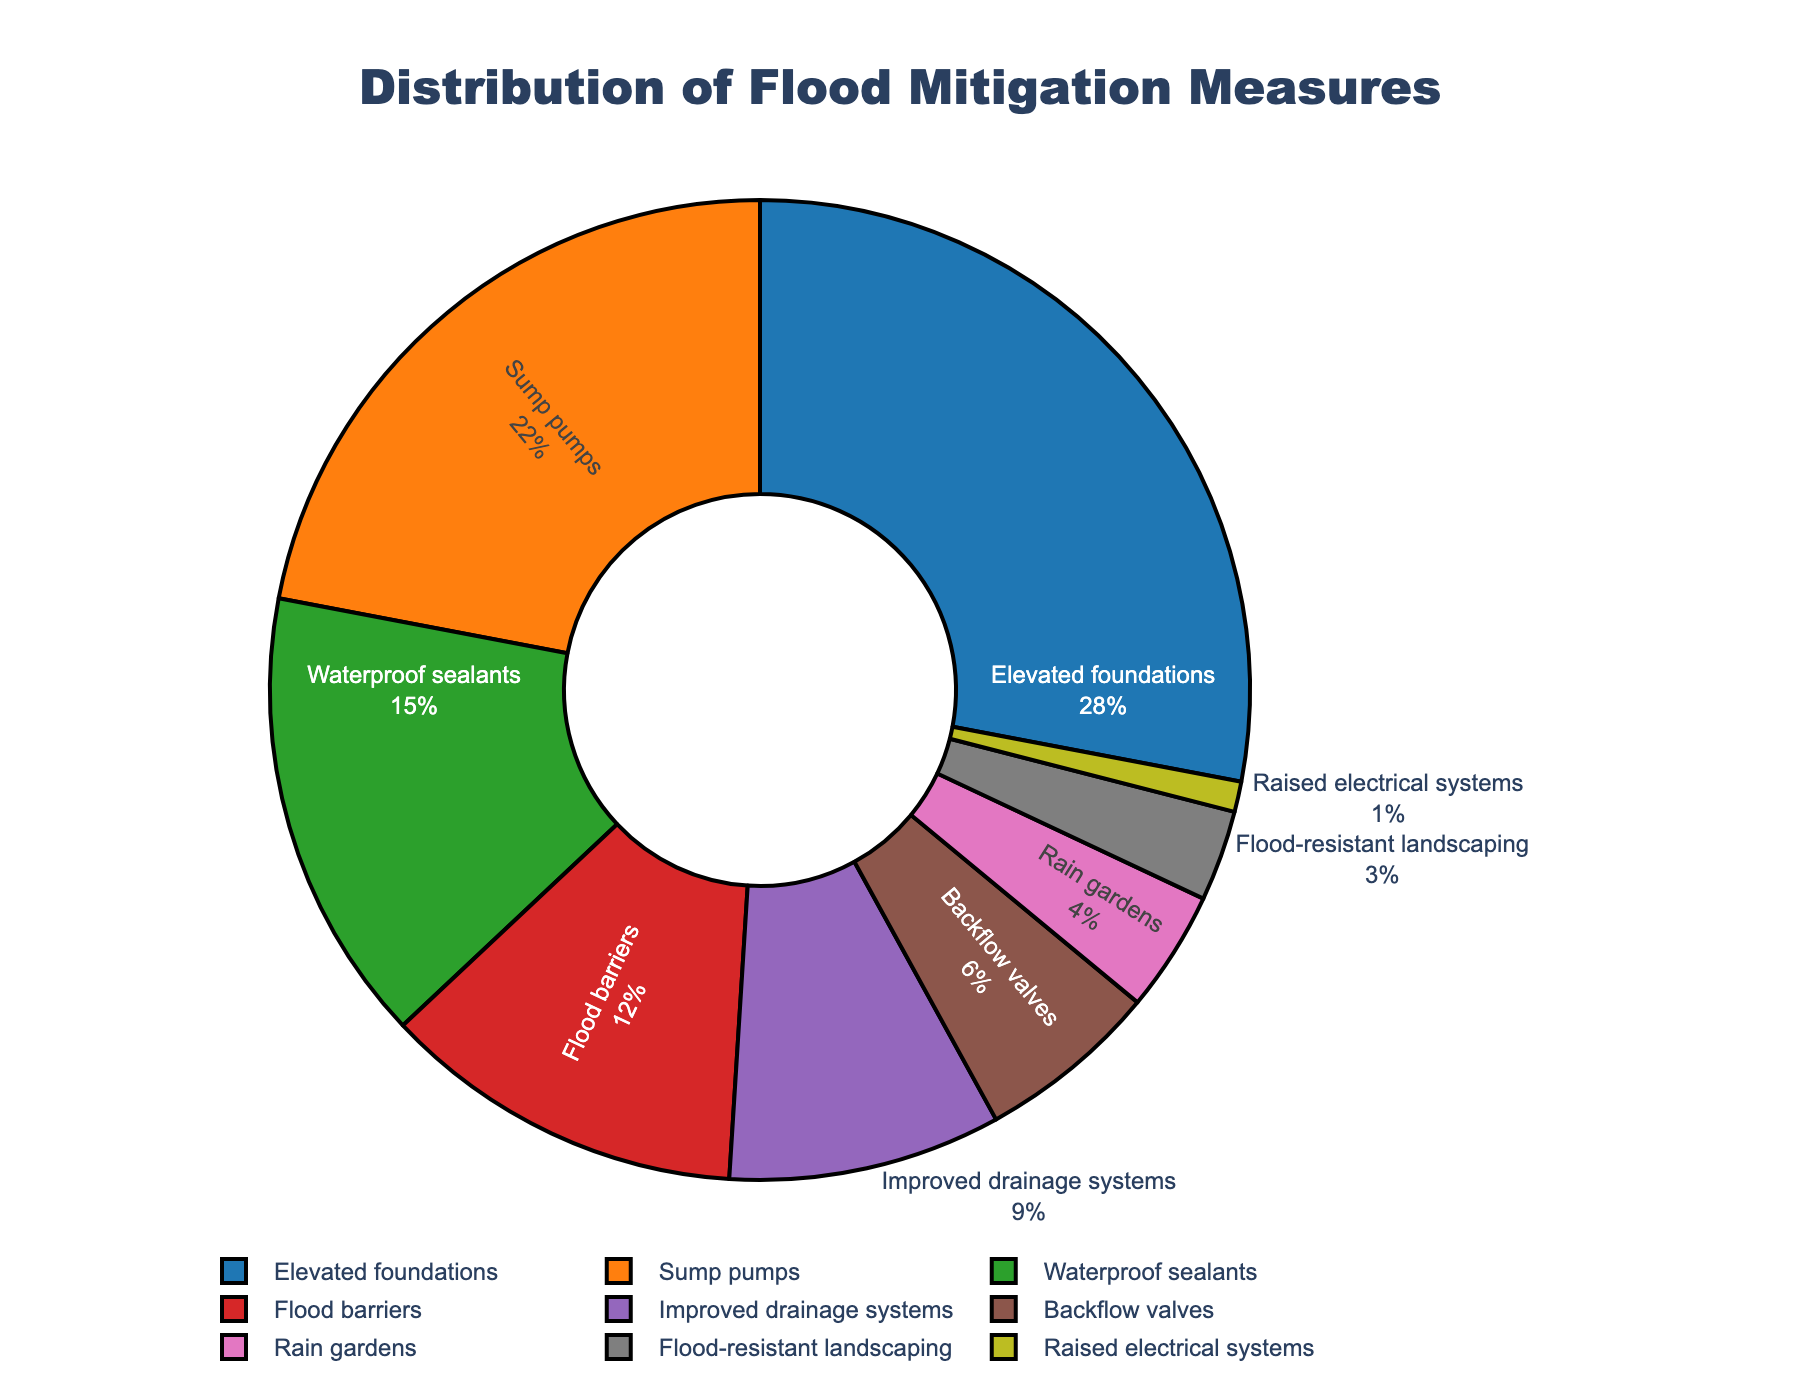Which flood mitigation measure has the highest adoption rate? By examining the pie chart, we identify the measure segment with the largest percentage. "Elevated foundations" has the highest adoption rate at 28%.
Answer: Elevated foundations What is the combined percentage of households that adopted sump pumps and waterproof sealants? To find the combined percentage, add the percentages of sump pumps (22%) and waterproof sealants (15%). Therefore, 22% + 15% = 37%.
Answer: 37% How does the adoption rate of flood barriers compare to that of improved drainage systems? We look at the two segments labeled "Flood barriers" and "Improved drainage systems". Flood barriers have a 12% adoption rate, while improved drainage systems have 9%. Thus, flood barriers have a higher adoption rate.
Answer: Flood barriers have a higher adoption rate What proportion of households adopted backflow valves compared to elevated foundations? To compare, divide the percentage of backflow valves (6%) by the percentage of elevated foundations (28%) and multiply by 100 to express it as a percentage. (6/28)*100 ≈ 21.43%.
Answer: Approximately 21.43% What is the least adopted flood mitigation measure? The smallest segment in the pie chart represents the measure with the lowest adoption rate, which is "Raised electrical systems" at 1%.
Answer: Raised electrical systems Between rain gardens and flood-resistant landscaping, which measure is more commonly adopted and by how much? Compare the percentages for rain gardens (4%) and flood-resistant landscaping (3%). Rain gardens are more commonly adopted. The difference is 4% - 3% = 1%.
Answer: Rain gardens by 1% What is the total percentage of households that adopted measures related to water management (sump pumps, improved drainage systems, backflow valves)? Sum the percentages of sump pumps (22%), improved drainage systems (9%), and backflow valves (6%). Therefore, 22% + 9% + 6% = 37%.
Answer: 37% How many more households adopted flood barriers compared to flood-resistant landscaping? Subtract the percentage of flood-resistant landscaping (3%) from the percentage of flood barriers (12%). Therefore, 12% - 3% = 9%.
Answer: 9% Which color represents the elevated foundations segment in the pie chart? Identify the segment labeled "Elevated foundations" and observe its color, which is represented by blue.
Answer: Blue Is the sum of the adoption percentages for measures other than the top three more than 50%? First, sum the percentages of the top three measures (elevated foundations: 28%, sump pumps: 22%, waterproof sealants: 15%). 28% + 22% + 15% = 65%. Subtract this from 100% to find the sum of the others: 100% - 65% = 35%, which is less than 50%.
Answer: No 